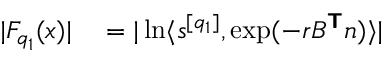<formula> <loc_0><loc_0><loc_500><loc_500>\begin{array} { r l } { | F _ { q _ { 1 } } ( x ) | } & = | \ln \langle s ^ { [ q _ { 1 } ] } , \exp ( - r B ^ { T } n ) \rangle | } \end{array}</formula> 